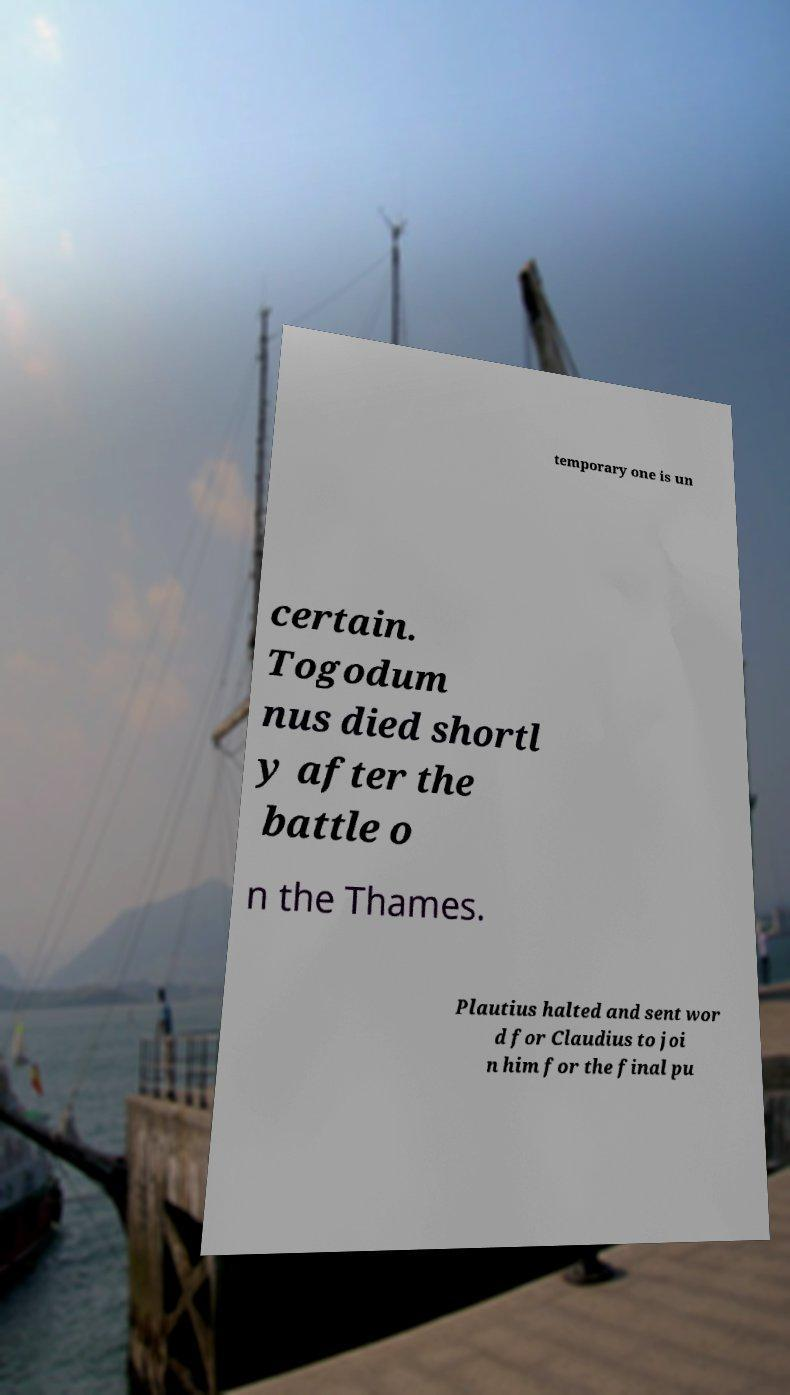There's text embedded in this image that I need extracted. Can you transcribe it verbatim? temporary one is un certain. Togodum nus died shortl y after the battle o n the Thames. Plautius halted and sent wor d for Claudius to joi n him for the final pu 